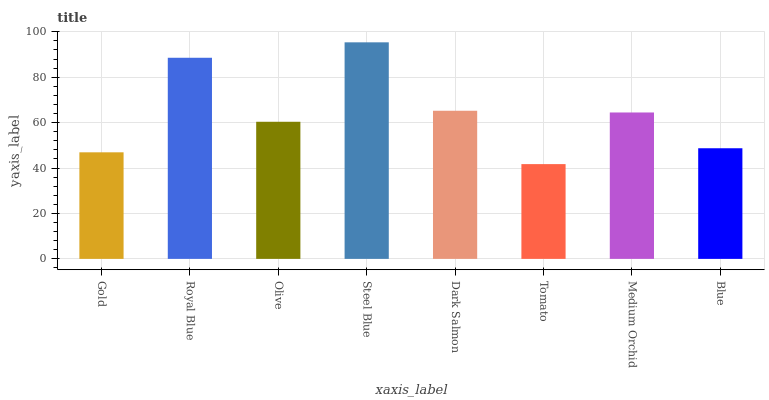Is Tomato the minimum?
Answer yes or no. Yes. Is Steel Blue the maximum?
Answer yes or no. Yes. Is Royal Blue the minimum?
Answer yes or no. No. Is Royal Blue the maximum?
Answer yes or no. No. Is Royal Blue greater than Gold?
Answer yes or no. Yes. Is Gold less than Royal Blue?
Answer yes or no. Yes. Is Gold greater than Royal Blue?
Answer yes or no. No. Is Royal Blue less than Gold?
Answer yes or no. No. Is Medium Orchid the high median?
Answer yes or no. Yes. Is Olive the low median?
Answer yes or no. Yes. Is Blue the high median?
Answer yes or no. No. Is Royal Blue the low median?
Answer yes or no. No. 